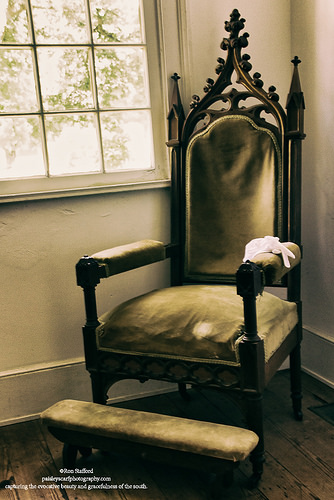<image>
Is there a chair behind the window? Yes. From this viewpoint, the chair is positioned behind the window, with the window partially or fully occluding the chair. Where is the chair in relation to the window? Is it under the window? Yes. The chair is positioned underneath the window, with the window above it in the vertical space. 